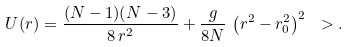Convert formula to latex. <formula><loc_0><loc_0><loc_500><loc_500>U ( r ) = \frac { ( N - 1 ) ( N - 3 ) } { 8 \, r ^ { 2 } } + \frac { g } { 8 N } \, \left ( r ^ { 2 } - r _ { 0 } ^ { 2 } \right ) ^ { 2 } \ > .</formula> 